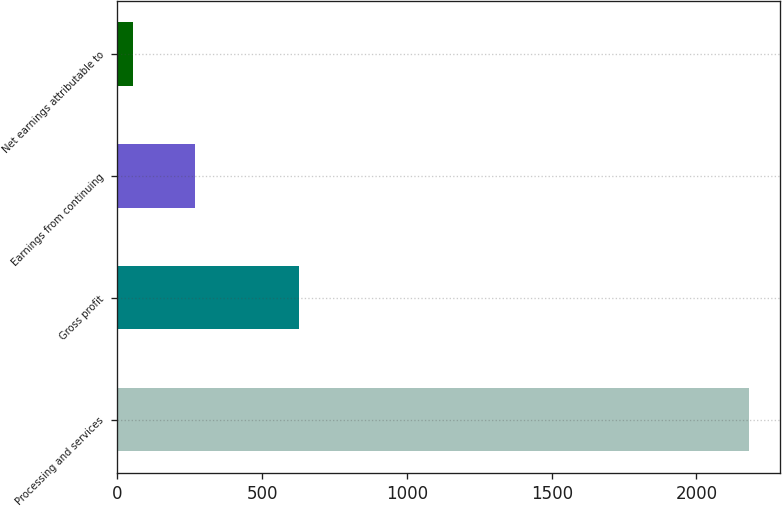<chart> <loc_0><loc_0><loc_500><loc_500><bar_chart><fcel>Processing and services<fcel>Gross profit<fcel>Earnings from continuing<fcel>Net earnings attributable to<nl><fcel>2181<fcel>628<fcel>267.6<fcel>55<nl></chart> 